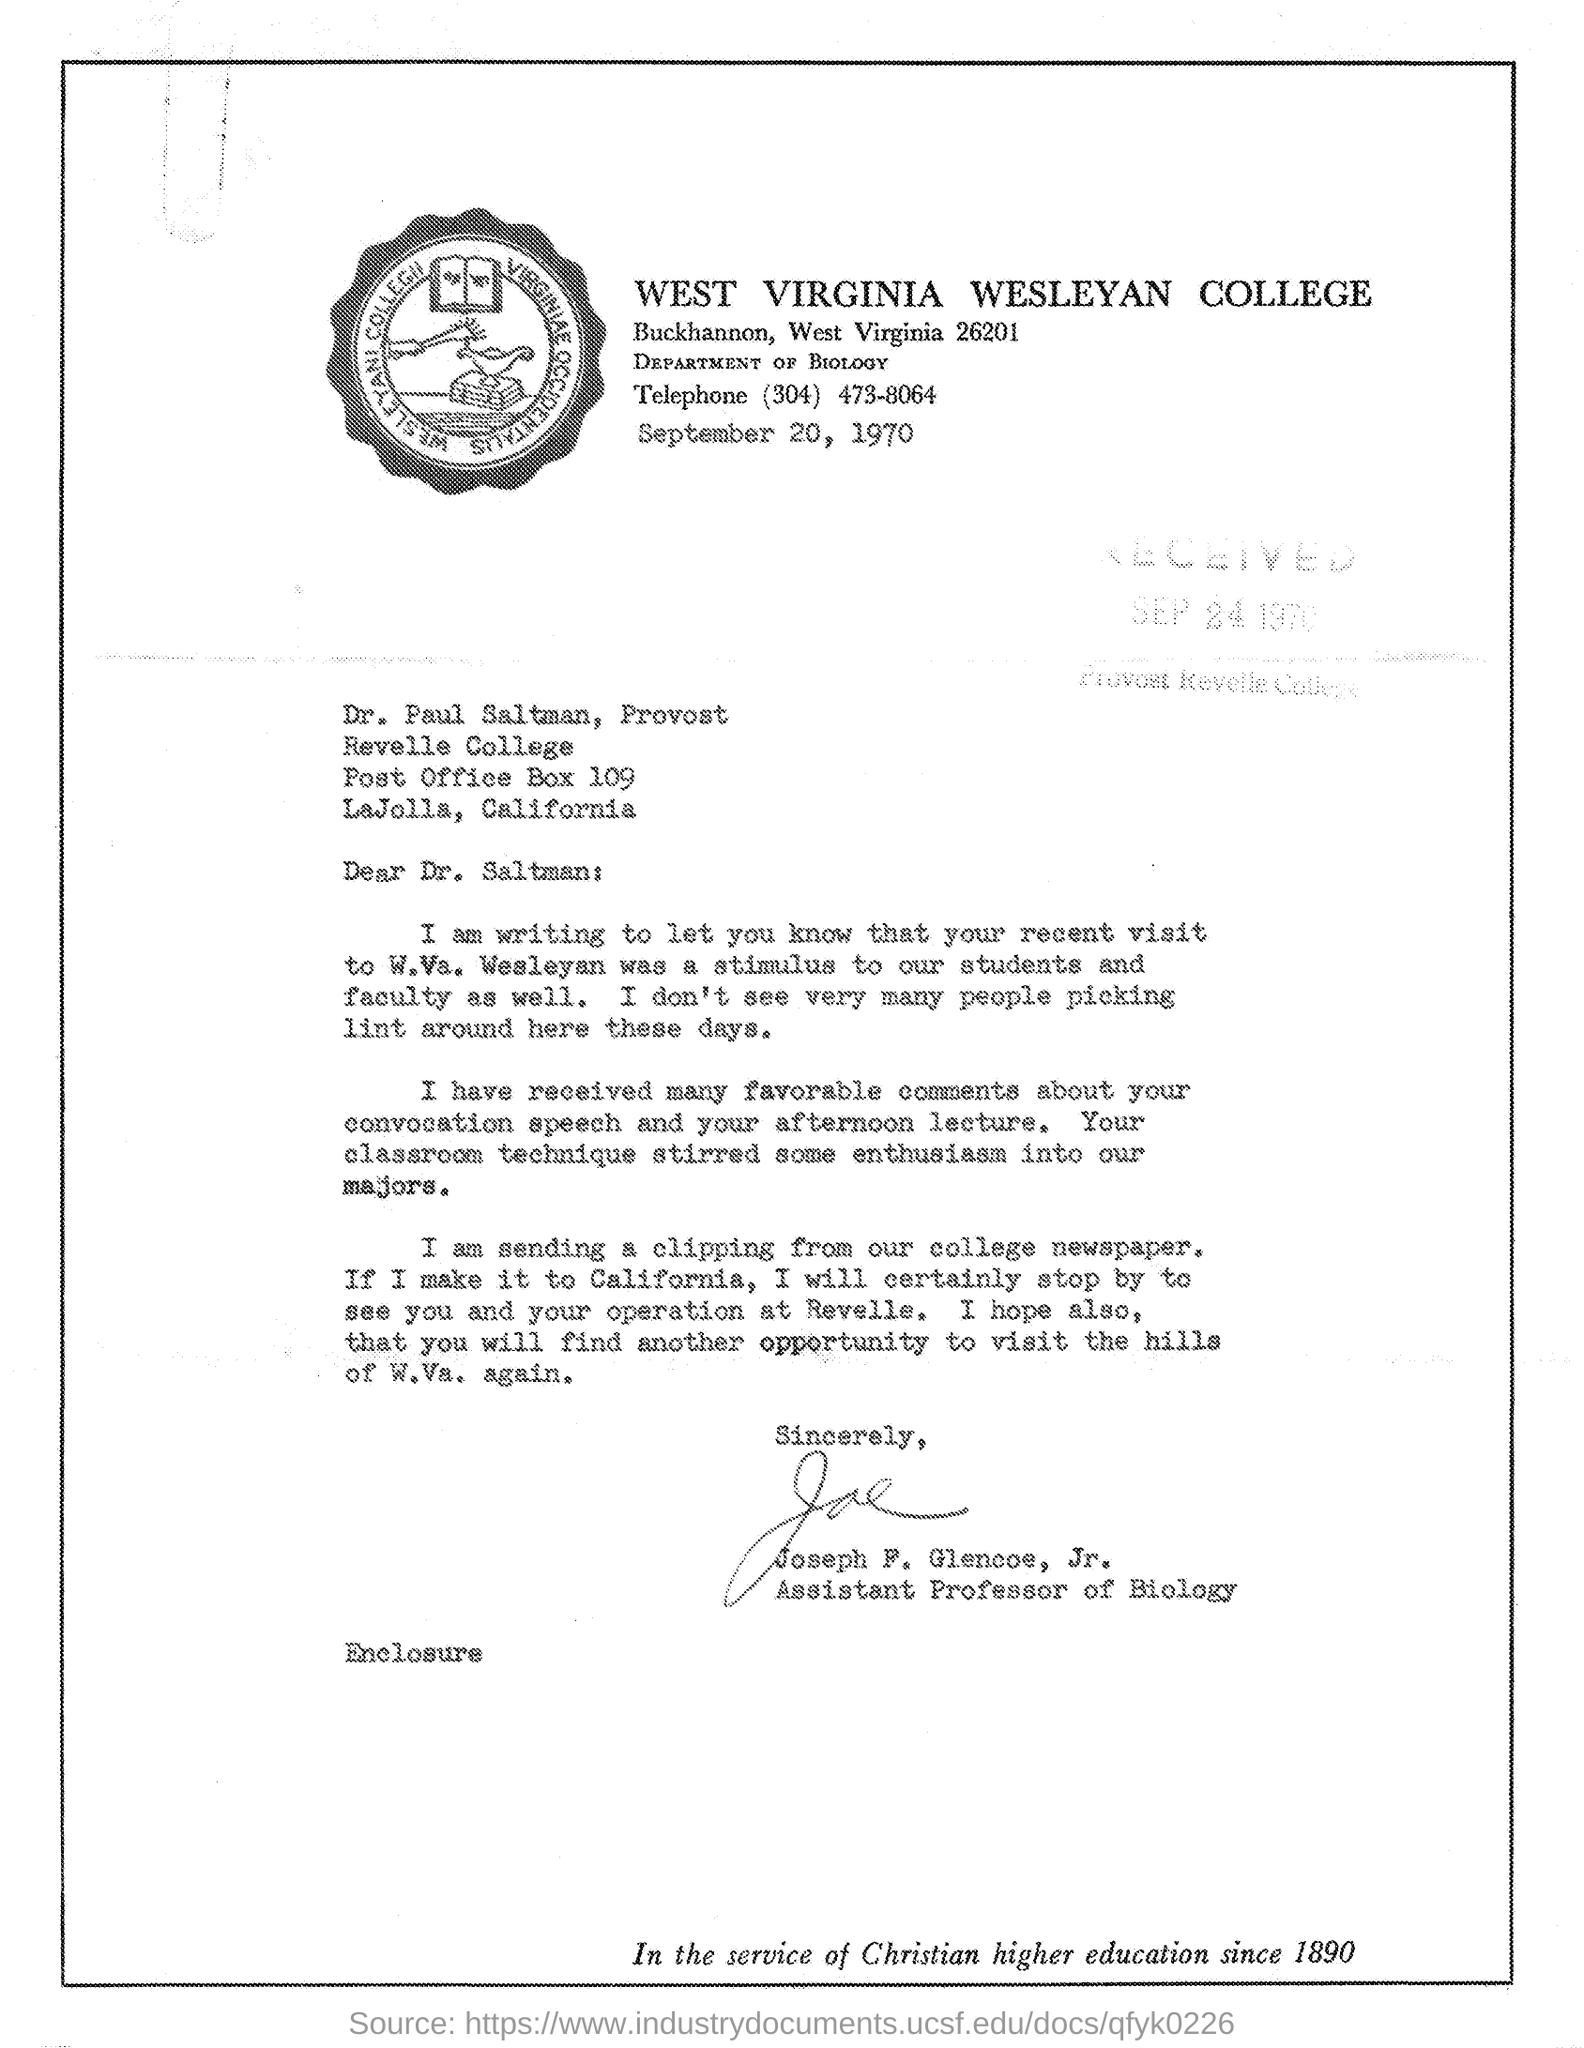What is designation of Joesph F. Glencoe
Your answer should be very brief. Assistant professor of Biology. 